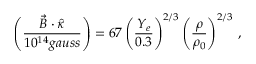<formula> <loc_0><loc_0><loc_500><loc_500>\left ( \frac { \vec { B } \cdot \hat { \kappa } } { 1 0 ^ { 1 4 } g a u s s } \right ) = 6 7 \left ( \frac { Y _ { e } } { 0 . 3 } \right ) ^ { 2 / 3 } \left ( \frac { \rho } { \rho _ { 0 } } \right ) ^ { 2 / 3 } \, ,</formula> 